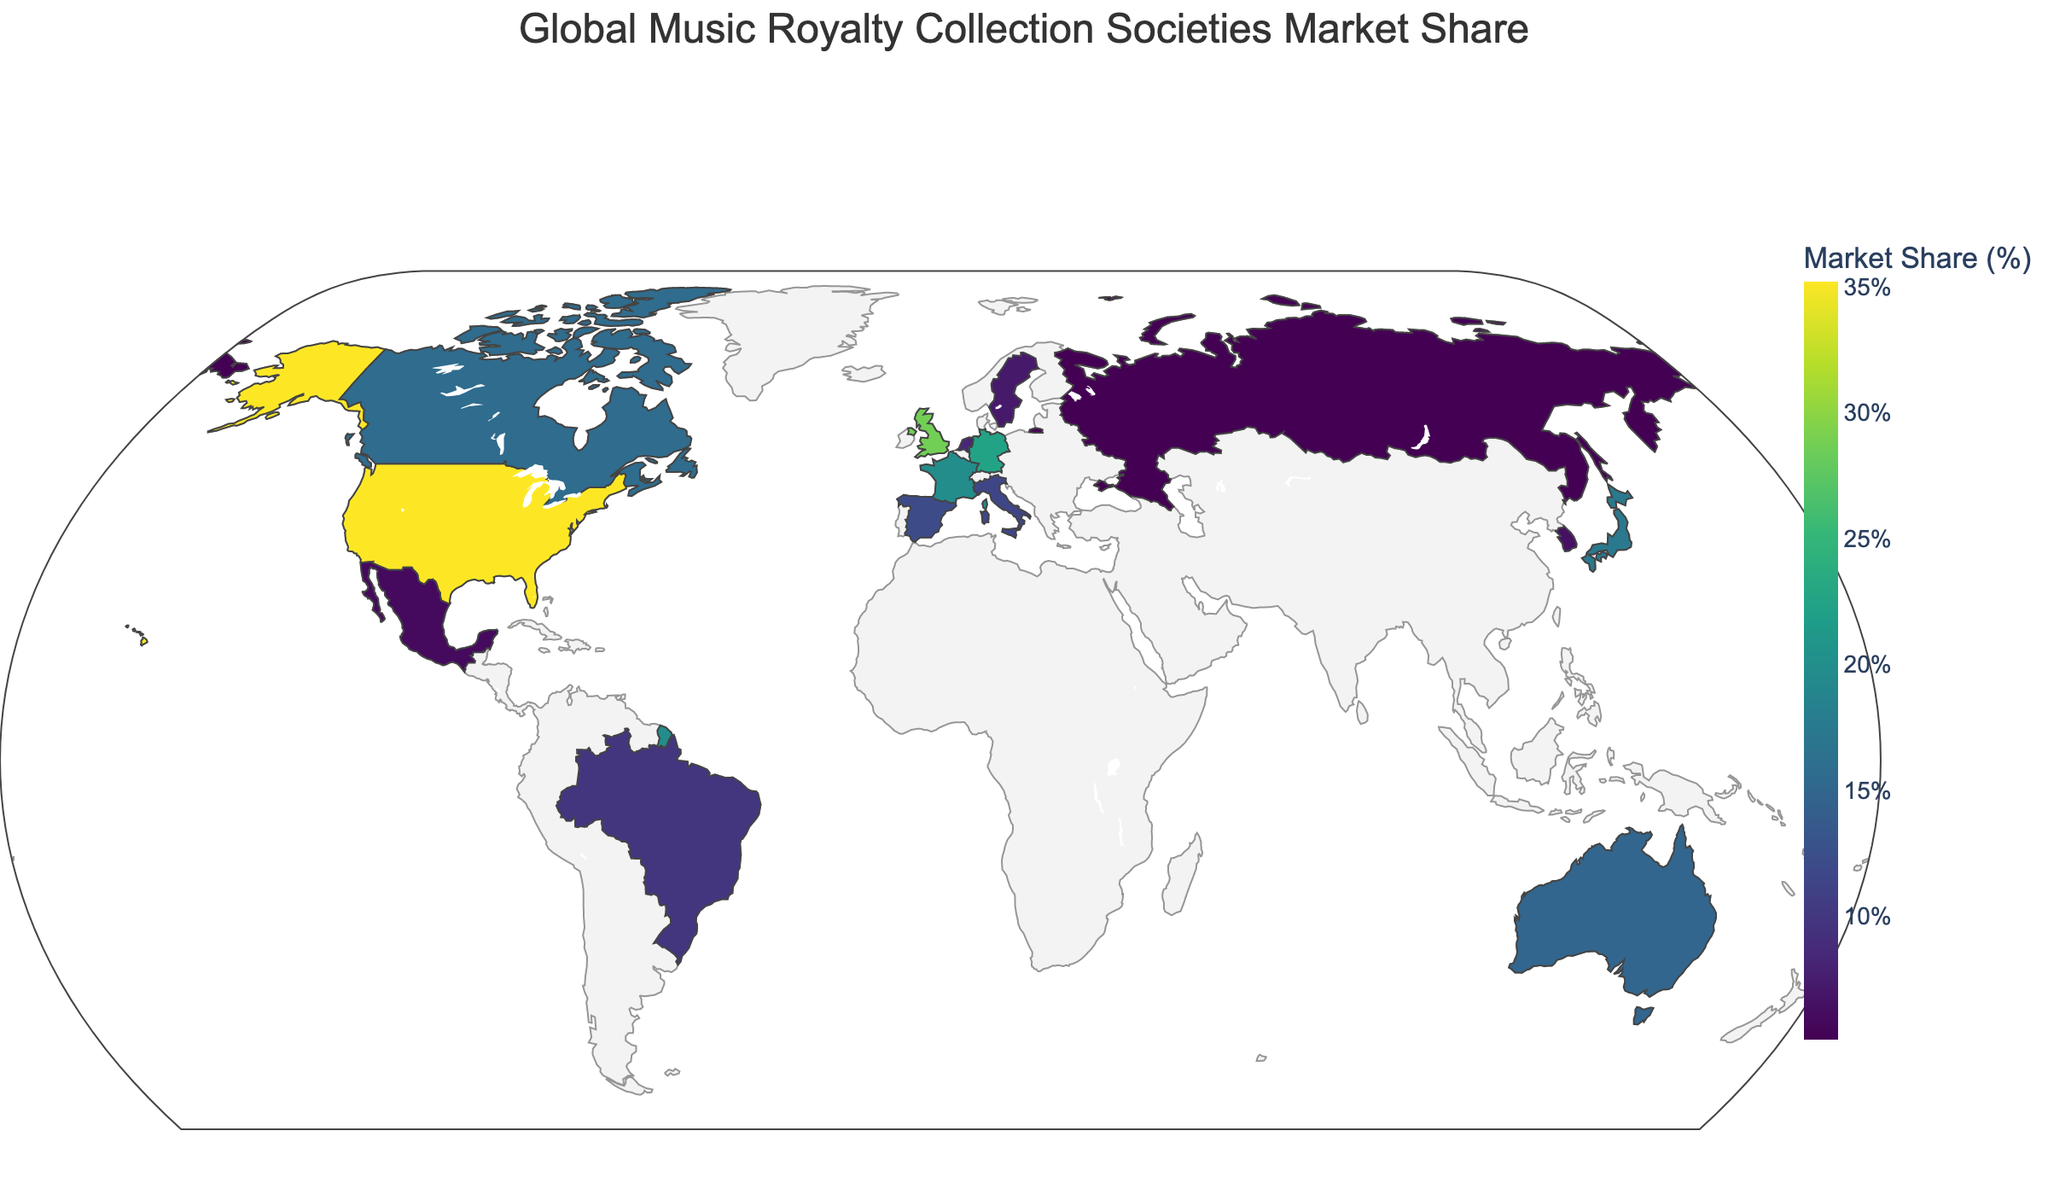What's the market share of ASCAP in the United States? The figure shows that ASCAP represents the United States with a market share value. By hovering over the United States on the map, we can see that ASCAP has a market share of 35.2%.
Answer: 35.2% Who has a higher market share, PRS for Music in the United Kingdom or GEMA in Germany? To compare the market shares, hover over the United Kingdom and Germany. PRS for Music has a market share of 28.7% in the UK and GEMA has 22.5% in Germany. Therefore, PRS for Music has a higher market share.
Answer: PRS for Music What's the average market share of the collection societies in Germany, France, and Japan? To find the average market share, sum the values and divide by the number of countries. For Germany, France, and Japan: (22.5 + 19.8 + 17.3) = 59.6, then divide by 3: 59.6 / 3 ≈ 19.87%.
Answer: 19.87% Which country has the smallest market share listed? Hover over each country and read the market share values. Russia's collection society, RAO, has the smallest market share at 5.1%.
Answer: Russia What is the total market share of SOCAN in Canada and APRA AMCOS in Australia? To find the total market share of these two societies, sum their market shares. SOCAN in Canada has 15.6% and APRA AMCOS in Australia has 14.9%. 15.6 + 14.9 = 30.5%.
Answer: 30.5% How much larger is ASCAP's market share than the average of BUMA/STEMRA (Netherlands) and STIM (Sweden)? First, calculate the average of BUMA/STEMRA and STIM: (8.4 + 7.2) / 2 = 7.8%. Then, find the difference between ASCAP’s market share (35.2%) and this average: 35.2 - 7.8 = 27.4%.
Answer: 27.4% Name the collection society in France and its market share. Hover over France to find the collection society and its market share. France's collection society is SACEM with a market share of 19.8%.
Answer: SACEM, 19.8% Is SACM's market share in Mexico greater than KOMCA's in South Korea? Hover over Mexico and South Korea to compare their market shares. SACM has 5.9% in Mexico, while KOMCA has 6.5% in South Korea. SACM's market share is not greater than KOMCA's.
Answer: No Which five countries have the highest market shares? Hover over each country and write down their market shares. The five highest are: United States (ASCAP, 35.2%), United Kingdom (PRS for Music, 28.7%), Germany (GEMA, 22.5%), France (SACEM, 19.8%), Japan (JASRAC, 17.3%).
Answer: United States, United Kingdom, Germany, France, Japan What is the combined market share of all European collection societies listed? Identify and sum the market shares of European societies: United Kingdom (28.7), Germany (22.5), France (19.8), Spain (12.1), Italy (11.5), Netherlands (8.4), Sweden (7.2). The combined total: 28.7 + 22.5 + 19.8 + 12.1 + 11.5 + 8.4 + 7.2 = 110.2%.
Answer: 110.2% 